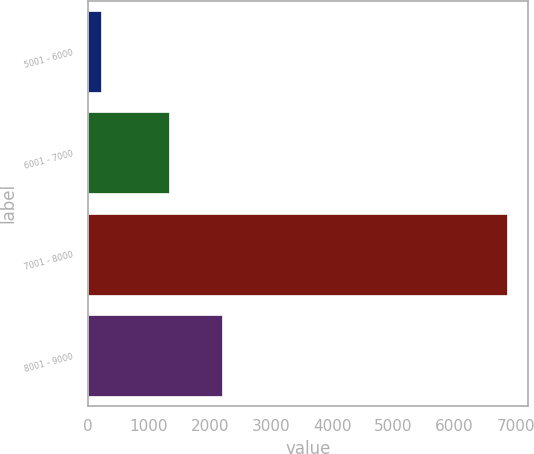Convert chart to OTSL. <chart><loc_0><loc_0><loc_500><loc_500><bar_chart><fcel>5001 - 6000<fcel>6001 - 7000<fcel>7001 - 8000<fcel>8001 - 9000<nl><fcel>211<fcel>1337<fcel>6858<fcel>2189<nl></chart> 